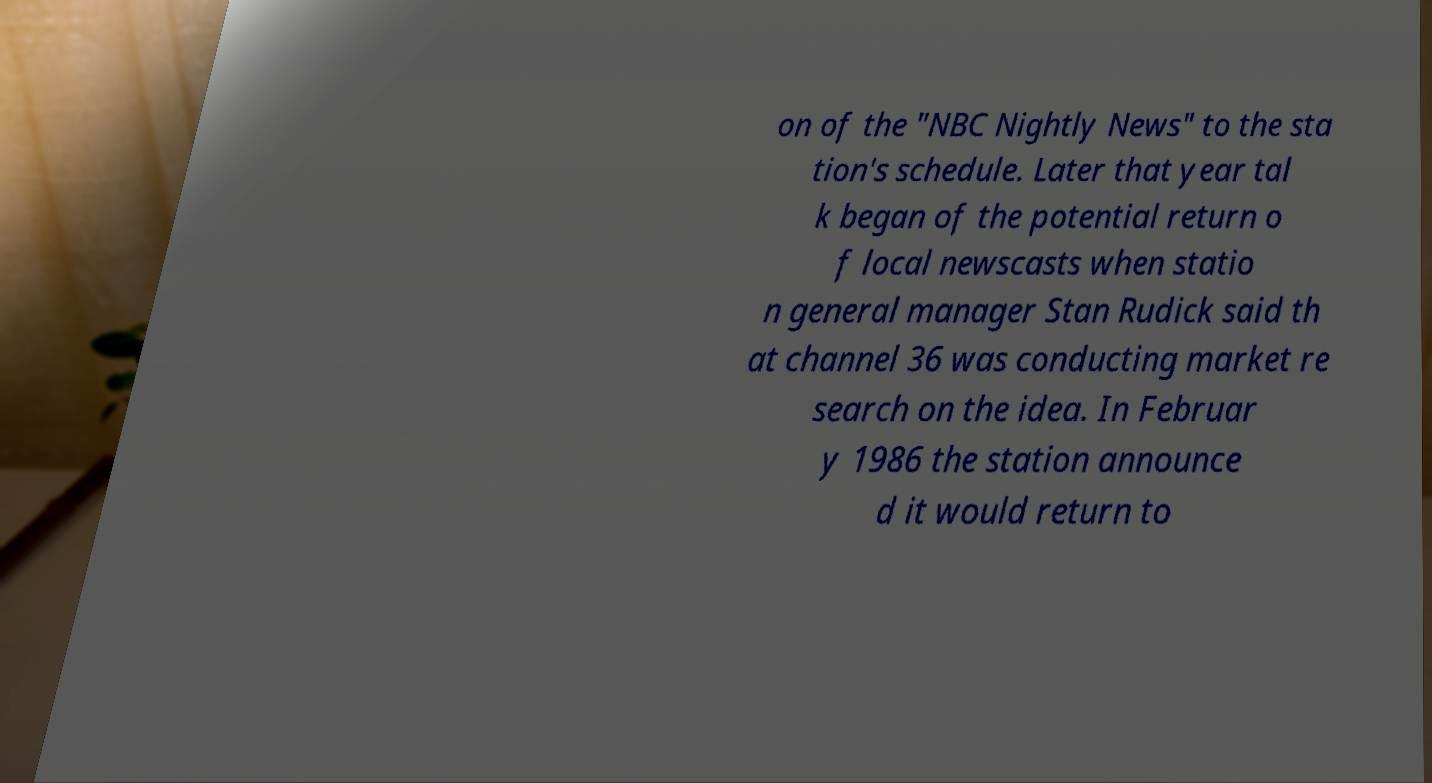Could you extract and type out the text from this image? on of the "NBC Nightly News" to the sta tion's schedule. Later that year tal k began of the potential return o f local newscasts when statio n general manager Stan Rudick said th at channel 36 was conducting market re search on the idea. In Februar y 1986 the station announce d it would return to 